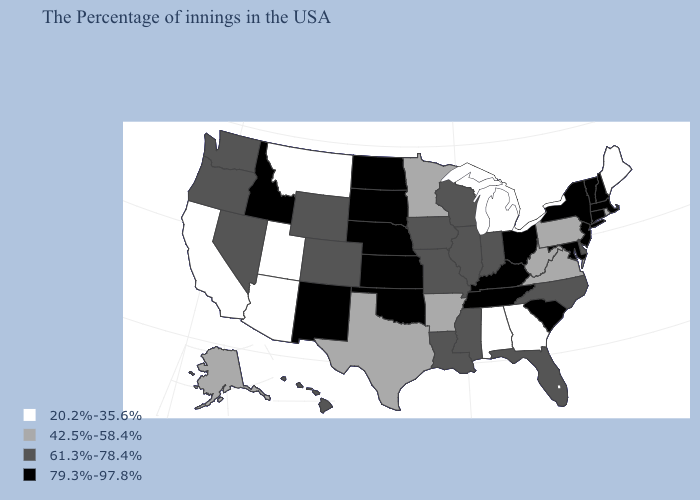Name the states that have a value in the range 42.5%-58.4%?
Concise answer only. Rhode Island, Pennsylvania, Virginia, West Virginia, Arkansas, Minnesota, Texas, Alaska. Does Missouri have the highest value in the USA?
Write a very short answer. No. Does the map have missing data?
Concise answer only. No. Is the legend a continuous bar?
Answer briefly. No. Name the states that have a value in the range 79.3%-97.8%?
Give a very brief answer. Massachusetts, New Hampshire, Vermont, Connecticut, New York, New Jersey, Maryland, South Carolina, Ohio, Kentucky, Tennessee, Kansas, Nebraska, Oklahoma, South Dakota, North Dakota, New Mexico, Idaho. What is the value of Texas?
Answer briefly. 42.5%-58.4%. What is the value of Rhode Island?
Keep it brief. 42.5%-58.4%. Among the states that border Oregon , does California have the lowest value?
Keep it brief. Yes. Does Massachusetts have the highest value in the Northeast?
Be succinct. Yes. Name the states that have a value in the range 79.3%-97.8%?
Write a very short answer. Massachusetts, New Hampshire, Vermont, Connecticut, New York, New Jersey, Maryland, South Carolina, Ohio, Kentucky, Tennessee, Kansas, Nebraska, Oklahoma, South Dakota, North Dakota, New Mexico, Idaho. Name the states that have a value in the range 61.3%-78.4%?
Keep it brief. Delaware, North Carolina, Florida, Indiana, Wisconsin, Illinois, Mississippi, Louisiana, Missouri, Iowa, Wyoming, Colorado, Nevada, Washington, Oregon, Hawaii. Which states have the highest value in the USA?
Quick response, please. Massachusetts, New Hampshire, Vermont, Connecticut, New York, New Jersey, Maryland, South Carolina, Ohio, Kentucky, Tennessee, Kansas, Nebraska, Oklahoma, South Dakota, North Dakota, New Mexico, Idaho. Is the legend a continuous bar?
Short answer required. No. Name the states that have a value in the range 42.5%-58.4%?
Give a very brief answer. Rhode Island, Pennsylvania, Virginia, West Virginia, Arkansas, Minnesota, Texas, Alaska. Does Oregon have a higher value than Arkansas?
Quick response, please. Yes. 